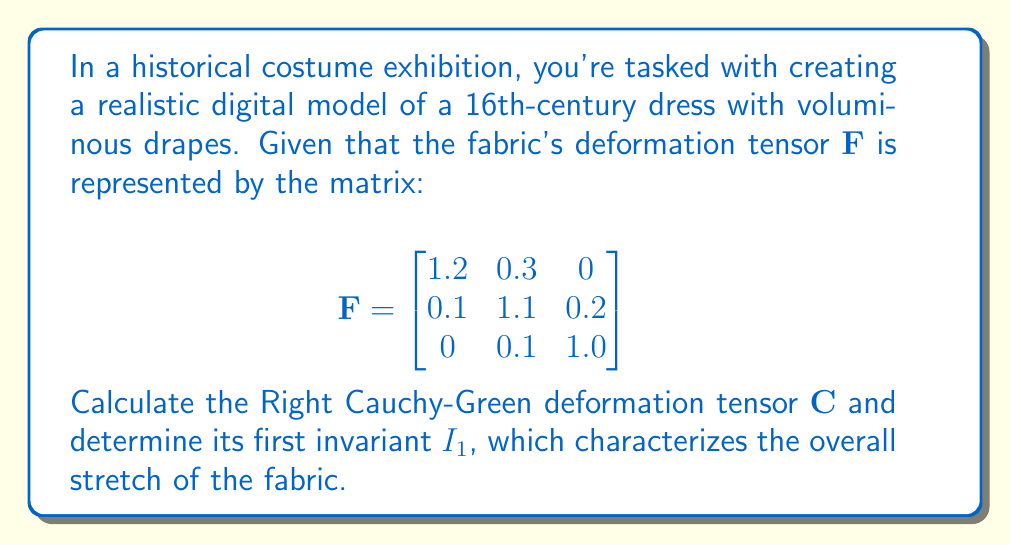Show me your answer to this math problem. To solve this problem, we'll follow these steps:

1) The Right Cauchy-Green deformation tensor $\mathbf{C}$ is defined as:

   $$\mathbf{C} = \mathbf{F}^T \mathbf{F}$$

   where $\mathbf{F}^T$ is the transpose of $\mathbf{F}$.

2) First, let's calculate $\mathbf{F}^T$:

   $$\mathbf{F}^T = \begin{bmatrix}
   1.2 & 0.1 & 0 \\
   0.3 & 1.1 & 0.1 \\
   0 & 0.2 & 1.0
   \end{bmatrix}$$

3) Now, we multiply $\mathbf{F}^T$ and $\mathbf{F}$:

   $$\mathbf{C} = \begin{bmatrix}
   1.2 & 0.1 & 0 \\
   0.3 & 1.1 & 0.1 \\
   0 & 0.2 & 1.0
   \end{bmatrix} \times 
   \begin{bmatrix}
   1.2 & 0.3 & 0 \\
   0.1 & 1.1 & 0.2 \\
   0 & 0.1 & 1.0
   \end{bmatrix}$$

4) Performing the matrix multiplication:

   $$\mathbf{C} = \begin{bmatrix}
   1.45 & 0.47 & 0.02 \\
   0.47 & 1.31 & 0.25 \\
   0.02 & 0.25 & 1.05
   \end{bmatrix}$$

5) The first invariant $I_1$ of $\mathbf{C}$ is the trace of the matrix, which is the sum of the diagonal elements:

   $$I_1 = \text{tr}(\mathbf{C}) = 1.45 + 1.31 + 1.05 = 3.81$$

This value of $I_1$ indicates that the fabric is experiencing overall stretch, as $I_1 > 3$ (the value for an undeformed state).
Answer: $I_1 = 3.81$ 